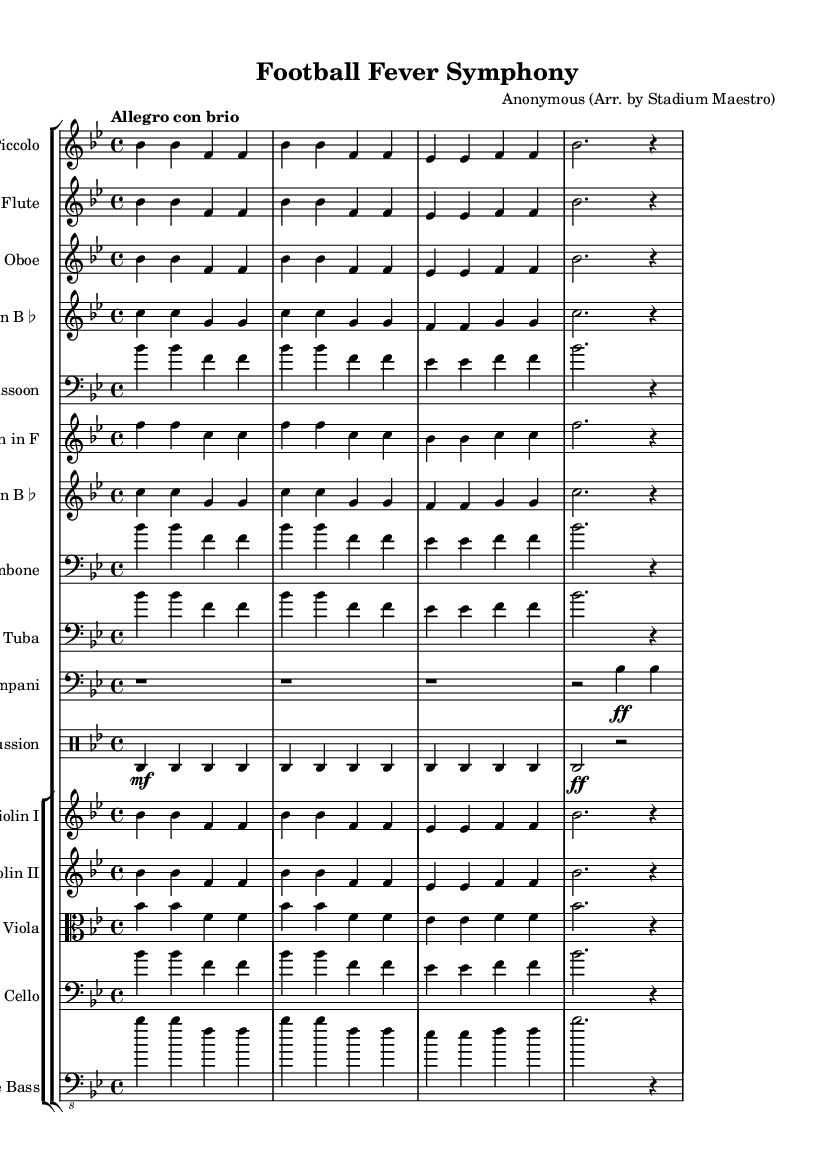What is the key signature of this music? The key signature is indicated by the two flats placed on the staff at the beginning of the piece. This means the piece is in B flat major.
Answer: B flat major What is the time signature of this music? The time signature is indicated at the beginning of the sheet music, showing 4/4, which means there are four beats in each measure and a quarter note receives one beat.
Answer: 4/4 What is the tempo marking for this composition? The tempo marking is found above the musical staff and reads "Allegro con brio," which indicates a lively and brisk tempo.
Answer: Allegro con brio How many measures are in the main theme? By counting the individual groups separated by the bar lines, we can see that the main theme has a total of four measures.
Answer: Four Which instruments are using the main theme in unison? Observing the staff groupings at the beginning, both the Piccolo and the Flute play the same notes in their respective staves, indicating they are in unison.
Answer: Piccolo, Flute What is the dynamic marking for the Timpani instrument in the second half of the score? The Timpani part shows a dynamic marking of "ff," which stands for fortissimo, indicating it should be played very loudly.
Answer: Fortissimo Which instrument has its part transposed up a whole step? The Clarinet in B flat part is transposed up a whole step (two half steps) so that it matches the concert pitch.
Answer: Clarinet in B flat 